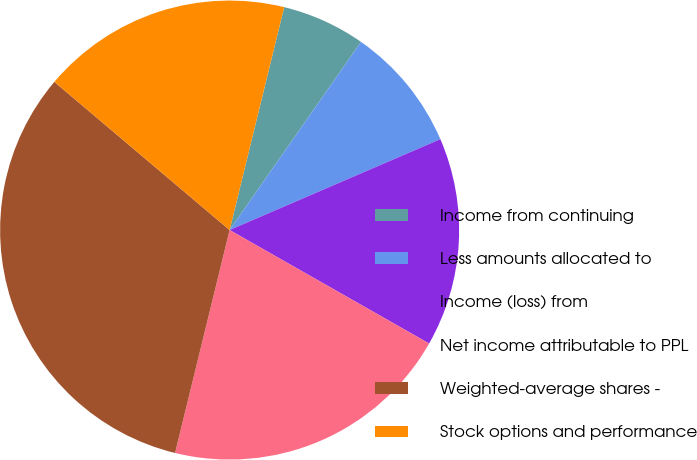<chart> <loc_0><loc_0><loc_500><loc_500><pie_chart><fcel>Income from continuing<fcel>Less amounts allocated to<fcel>Income (loss) from<fcel>Net income attributable to PPL<fcel>Weighted-average shares -<fcel>Stock options and performance<nl><fcel>5.88%<fcel>8.82%<fcel>14.71%<fcel>20.59%<fcel>32.35%<fcel>17.65%<nl></chart> 